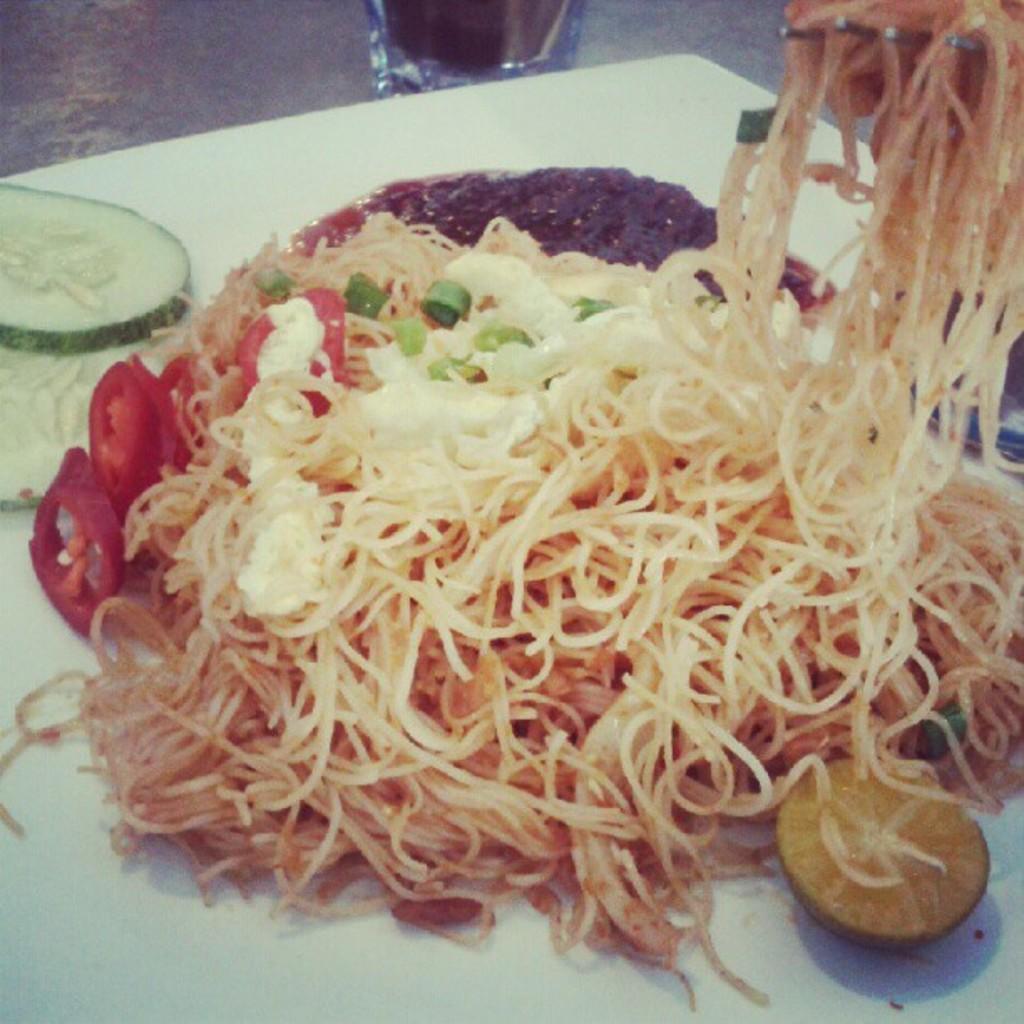How would you summarize this image in a sentence or two? In this image there is a plate on which there are noodles,tomato slices, sauce and a lemon piece beside it. 